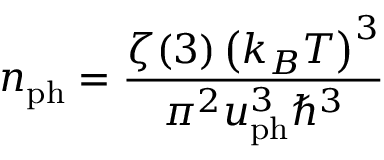Convert formula to latex. <formula><loc_0><loc_0><loc_500><loc_500>n _ { p h } = \frac { \zeta ( 3 ) \left ( k _ { B } T \right ) ^ { 3 } } { \pi ^ { 2 } u _ { p h } ^ { 3 } \hbar { ^ } { 3 } }</formula> 